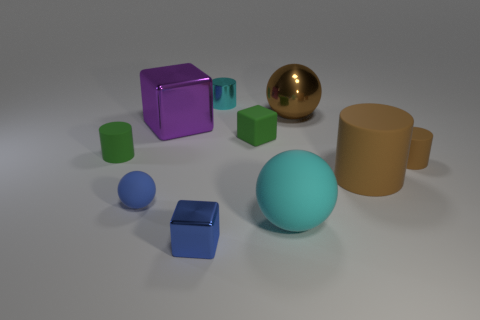Subtract 1 balls. How many balls are left? 2 Subtract all balls. How many objects are left? 7 Add 9 small green cylinders. How many small green cylinders exist? 10 Subtract 0 yellow spheres. How many objects are left? 10 Subtract all small blue shiny blocks. Subtract all tiny cyan metallic cylinders. How many objects are left? 8 Add 8 blue objects. How many blue objects are left? 10 